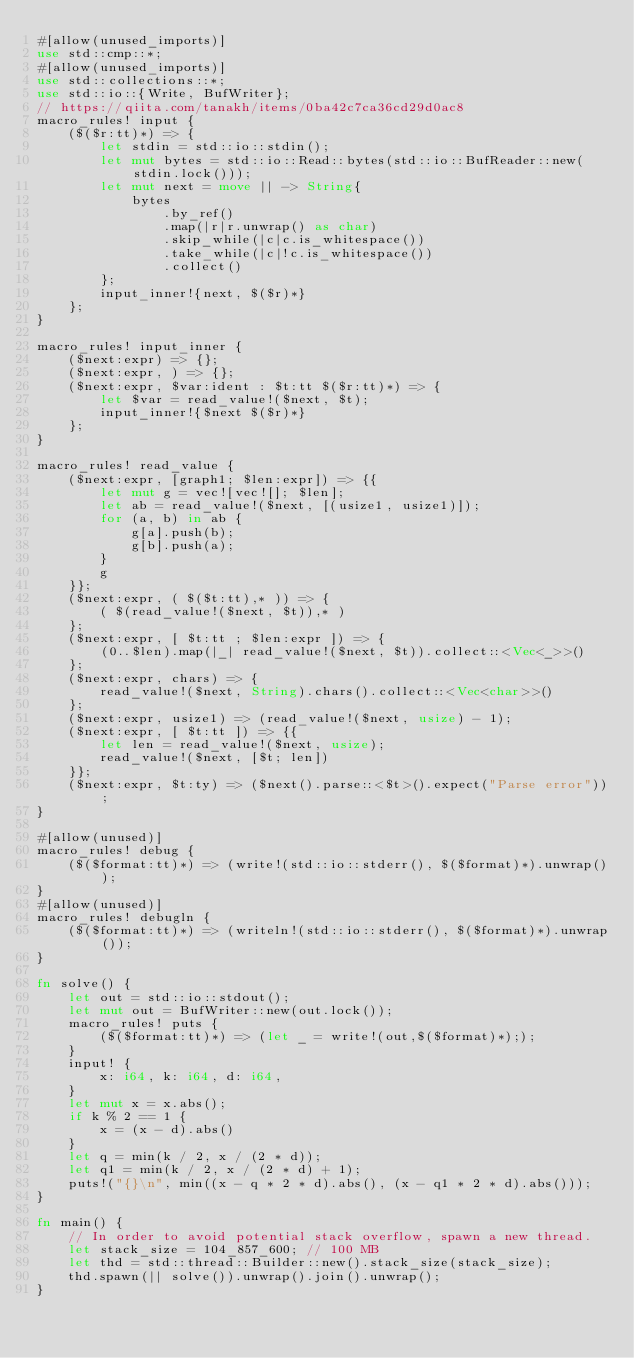Convert code to text. <code><loc_0><loc_0><loc_500><loc_500><_Rust_>#[allow(unused_imports)]
use std::cmp::*;
#[allow(unused_imports)]
use std::collections::*;
use std::io::{Write, BufWriter};
// https://qiita.com/tanakh/items/0ba42c7ca36cd29d0ac8
macro_rules! input {
    ($($r:tt)*) => {
        let stdin = std::io::stdin();
        let mut bytes = std::io::Read::bytes(std::io::BufReader::new(stdin.lock()));
        let mut next = move || -> String{
            bytes
                .by_ref()
                .map(|r|r.unwrap() as char)
                .skip_while(|c|c.is_whitespace())
                .take_while(|c|!c.is_whitespace())
                .collect()
        };
        input_inner!{next, $($r)*}
    };
}

macro_rules! input_inner {
    ($next:expr) => {};
    ($next:expr, ) => {};
    ($next:expr, $var:ident : $t:tt $($r:tt)*) => {
        let $var = read_value!($next, $t);
        input_inner!{$next $($r)*}
    };
}

macro_rules! read_value {
    ($next:expr, [graph1; $len:expr]) => {{
        let mut g = vec![vec![]; $len];
        let ab = read_value!($next, [(usize1, usize1)]);
        for (a, b) in ab {
            g[a].push(b);
            g[b].push(a);
        }
        g
    }};
    ($next:expr, ( $($t:tt),* )) => {
        ( $(read_value!($next, $t)),* )
    };
    ($next:expr, [ $t:tt ; $len:expr ]) => {
        (0..$len).map(|_| read_value!($next, $t)).collect::<Vec<_>>()
    };
    ($next:expr, chars) => {
        read_value!($next, String).chars().collect::<Vec<char>>()
    };
    ($next:expr, usize1) => (read_value!($next, usize) - 1);
    ($next:expr, [ $t:tt ]) => {{
        let len = read_value!($next, usize);
        read_value!($next, [$t; len])
    }};
    ($next:expr, $t:ty) => ($next().parse::<$t>().expect("Parse error"));
}

#[allow(unused)]
macro_rules! debug {
    ($($format:tt)*) => (write!(std::io::stderr(), $($format)*).unwrap());
}
#[allow(unused)]
macro_rules! debugln {
    ($($format:tt)*) => (writeln!(std::io::stderr(), $($format)*).unwrap());
}

fn solve() {
    let out = std::io::stdout();
    let mut out = BufWriter::new(out.lock());
    macro_rules! puts {
        ($($format:tt)*) => (let _ = write!(out,$($format)*););
    }
    input! {
        x: i64, k: i64, d: i64,
    }
    let mut x = x.abs();
    if k % 2 == 1 {
        x = (x - d).abs()
    }
    let q = min(k / 2, x / (2 * d));
    let q1 = min(k / 2, x / (2 * d) + 1);
    puts!("{}\n", min((x - q * 2 * d).abs(), (x - q1 * 2 * d).abs()));
}

fn main() {
    // In order to avoid potential stack overflow, spawn a new thread.
    let stack_size = 104_857_600; // 100 MB
    let thd = std::thread::Builder::new().stack_size(stack_size);
    thd.spawn(|| solve()).unwrap().join().unwrap();
}
</code> 